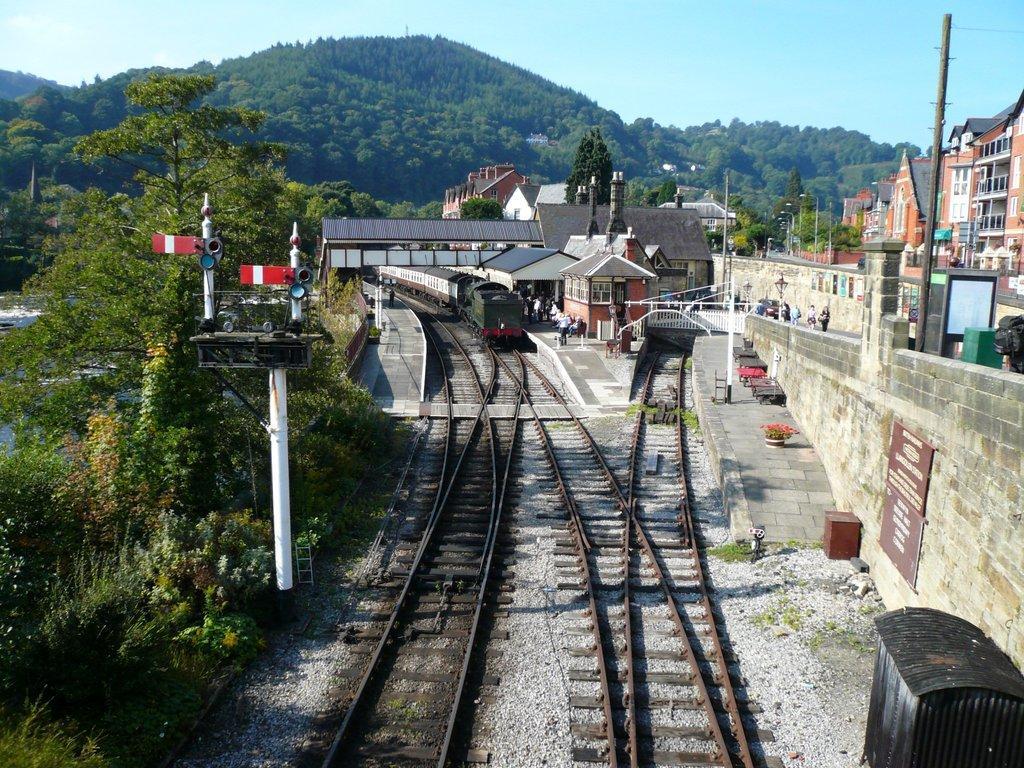Describe this image in one or two sentences. In this picture we can see a train on a railway track, trees, buildings, poles and some people standing on a platform, mountains and in the background we can see the sky. 